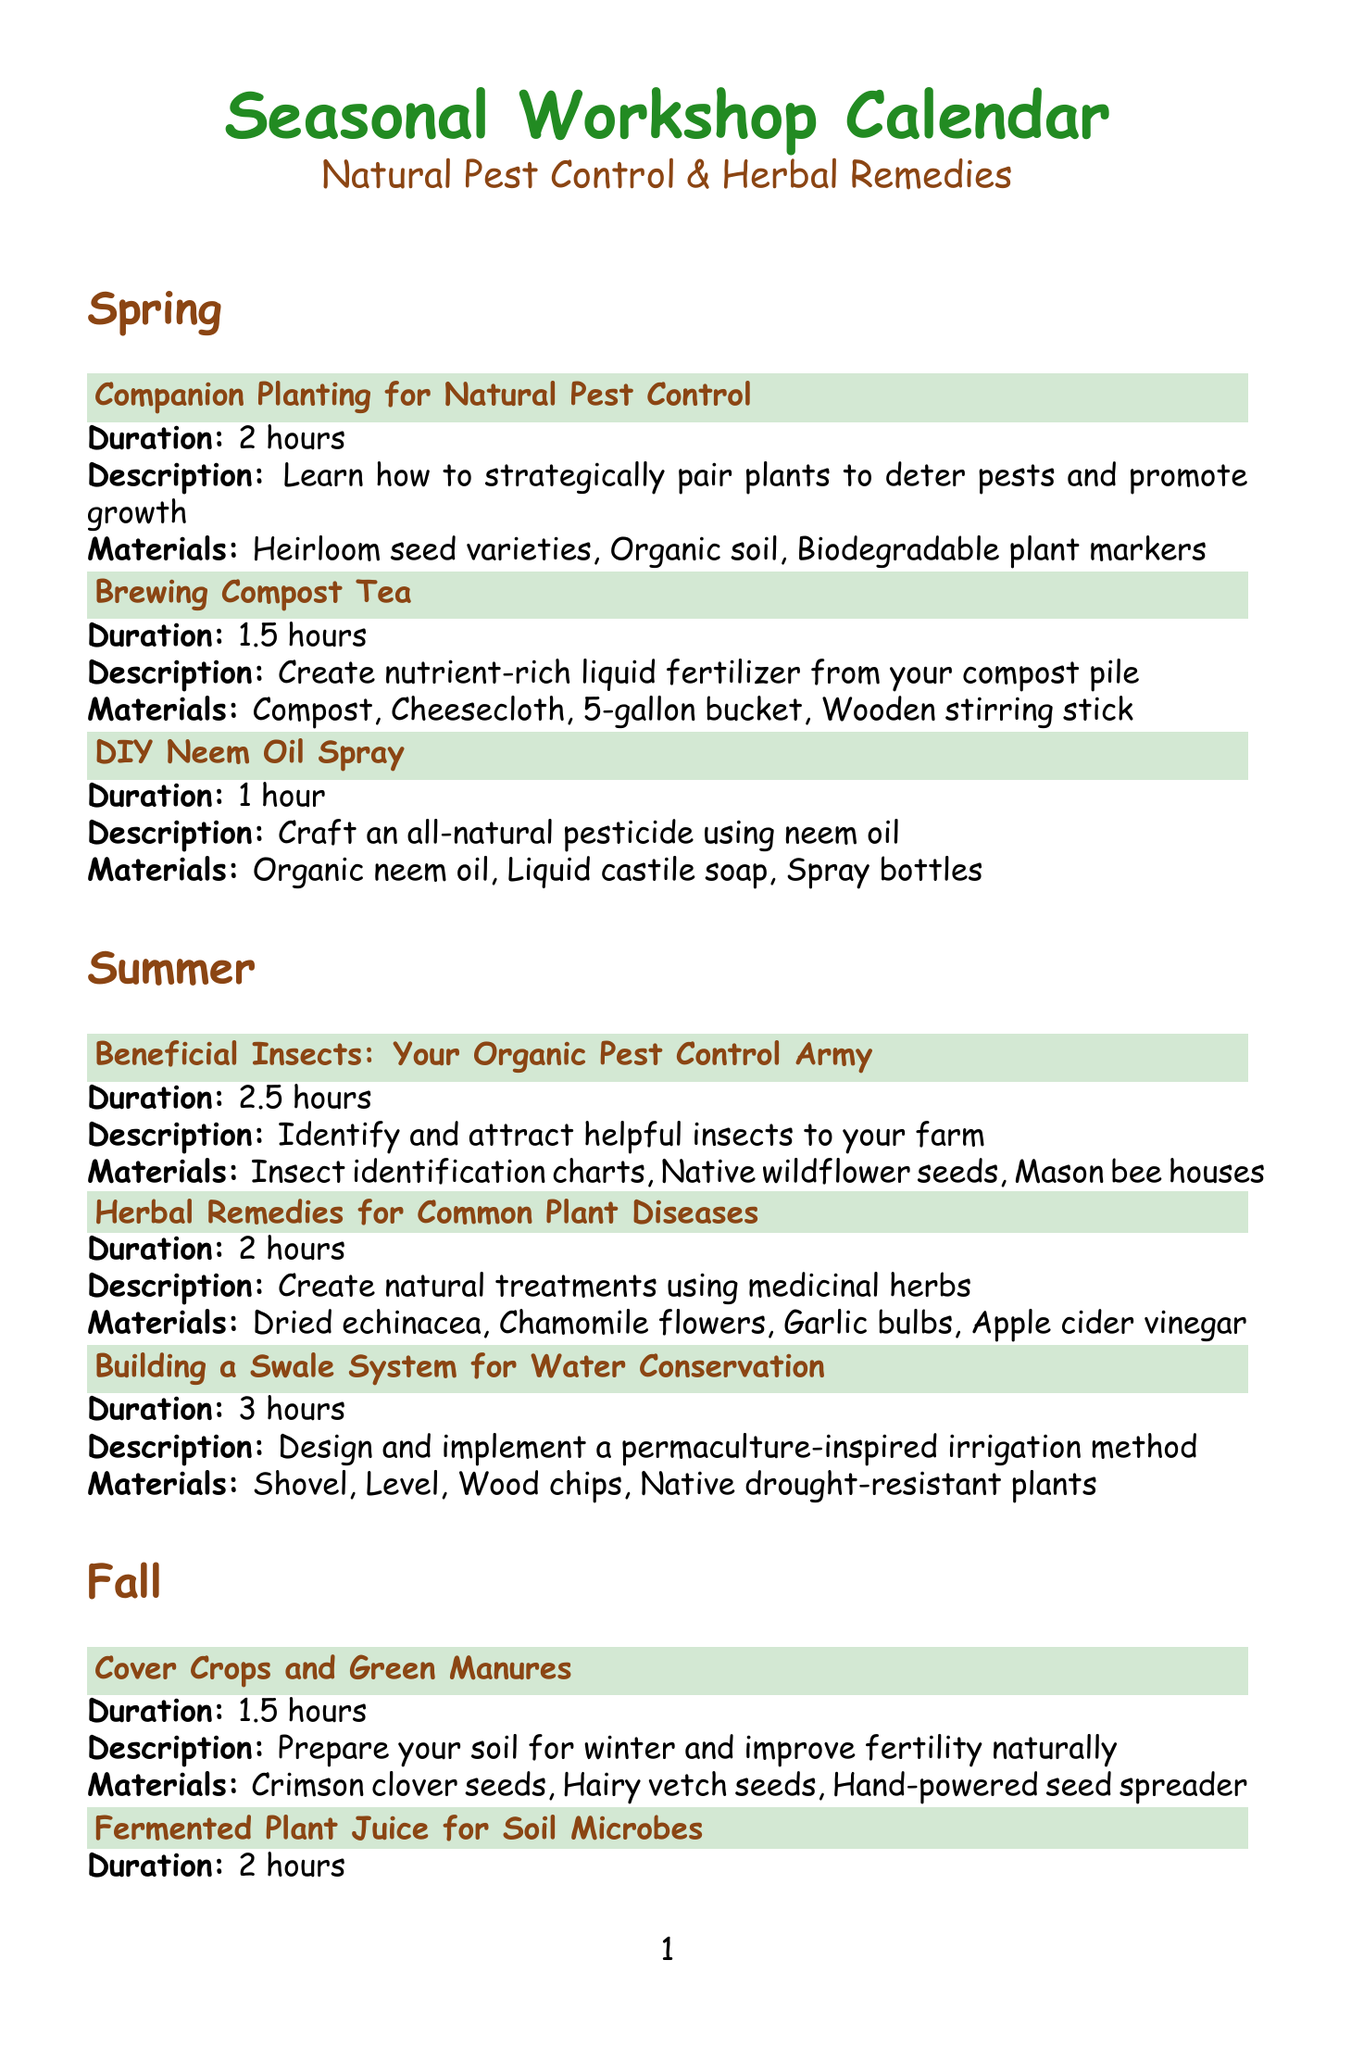What is the title of the workshop in Spring about natural pest control? The title of the workshop is specifically focused on pairing plants to deter pests and promote growth in Spring.
Answer: Companion Planting for Natural Pest Control How long does the "Herbal Remedies for Common Plant Diseases" workshop last? The duration of the workshop is mentioned clearly in the Summer section.
Answer: 2 hours Which materials are required for the "DIY Neem Oil Spray"? The materials for this workshop are listed as necessary components for crafting a natural pesticide.
Answer: Organic neem oil, Liquid castile soap, Spray bottles What is the focus of the Winter workshop titled "Planning Your Organic Crop Rotation"? The description indicates that this workshop is about designing a multi-year rotation plan for pest management and soil health.
Answer: Pest management and soil health In which season is the workshop on "Natural Slug and Snail Control" offered? The season for this workshop is specified in the Fall section of the document.
Answer: Fall How many workshops are offered in the Summer season? The total number of workshops in the Summer season is presented in the workshops list.
Answer: 3 What type of flooring material is used for the workshop "Homemade Organic Potting Mix"? The materials listed for creating potting mix include a specific component that serves as a base for growing medium.
Answer: Coconut coir Which workshop helps identify beneficial insects? The title of the workshop focusing on beneficial insects is detailed in the Summer section.
Answer: Beneficial Insects: Your Organic Pest Control Army 